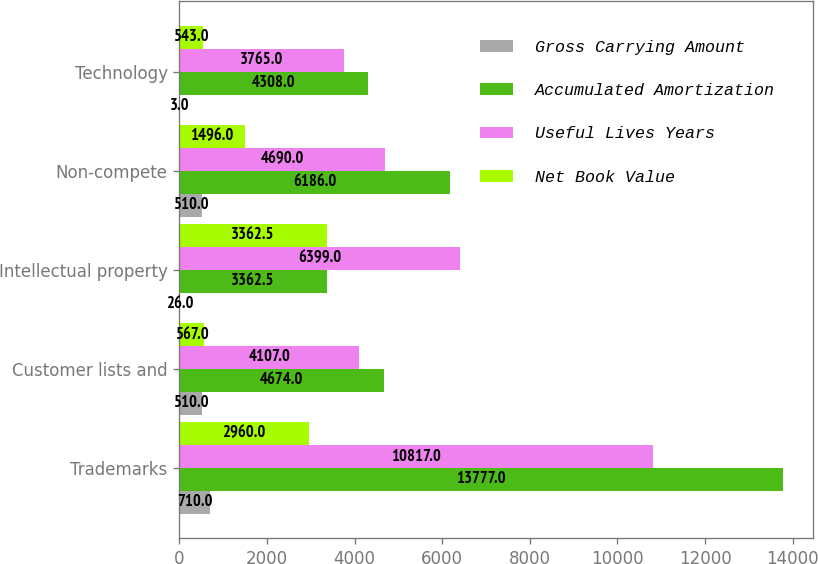Convert chart to OTSL. <chart><loc_0><loc_0><loc_500><loc_500><stacked_bar_chart><ecel><fcel>Trademarks<fcel>Customer lists and<fcel>Intellectual property<fcel>Non-compete<fcel>Technology<nl><fcel>Gross Carrying Amount<fcel>710<fcel>510<fcel>26<fcel>510<fcel>3<nl><fcel>Accumulated Amortization<fcel>13777<fcel>4674<fcel>3362.5<fcel>6186<fcel>4308<nl><fcel>Useful Lives Years<fcel>10817<fcel>4107<fcel>6399<fcel>4690<fcel>3765<nl><fcel>Net Book Value<fcel>2960<fcel>567<fcel>3362.5<fcel>1496<fcel>543<nl></chart> 